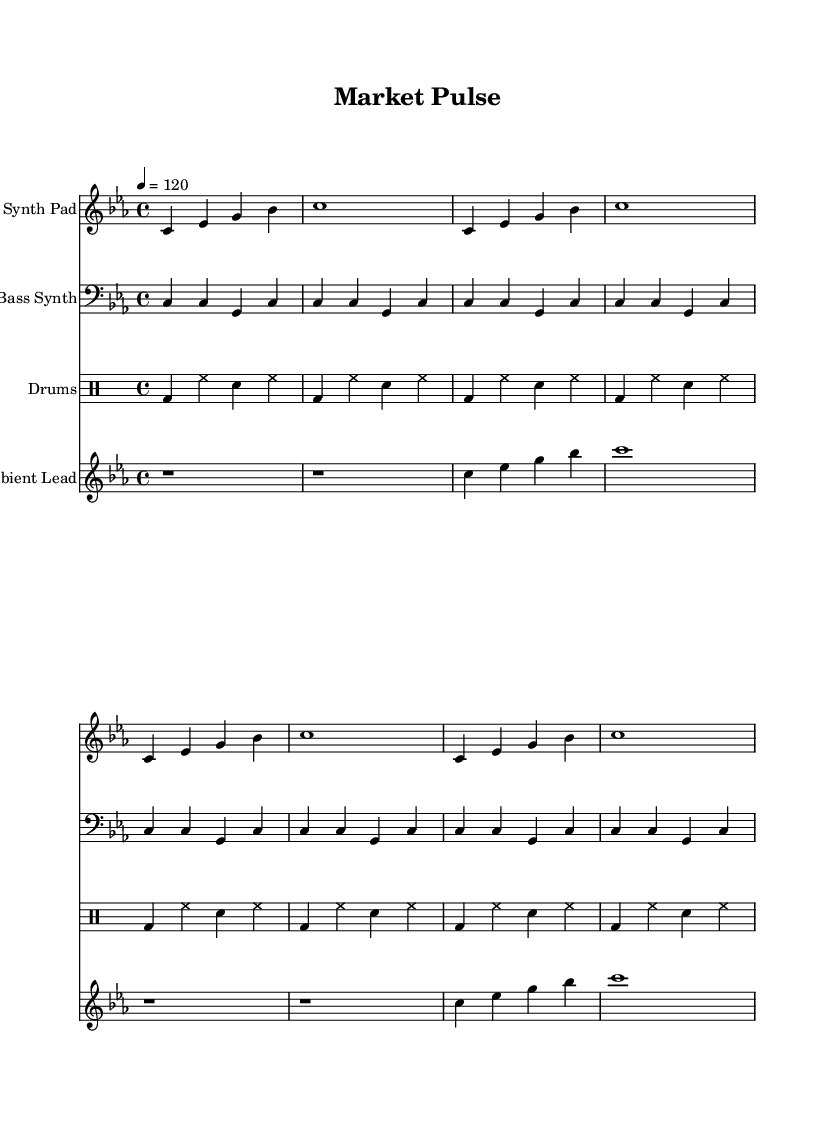What is the key signature of this music? The key signature is C minor, which has three flats: B flat, E flat, and A flat. This is indicated at the beginning of the staff.
Answer: C minor What is the time signature? The time signature is 4/4, which means there are four beats in each measure and the quarter note receives one beat. This is shown at the start of the piece after the key signature.
Answer: 4/4 What is the tempo marking? The tempo marking indicates a tempo of 120 beats per minute, which is notated at the beginning of the score as "4 = 120".
Answer: 120 How many measures are in the synth pad part? The synth pad part contains a total of eight measures, as counted from the beginning to the end of its section.
Answer: 8 What is the primary rhythmic pattern used in the drums part? The primary rhythmic pattern consists of a kick drum on the first and third beats and hi-hat on the second and fourth beats with snare accents in between, typical for house music.
Answer: Kick and hi-hat What note is sustained in the ambient lead during the first two measures? The ambient lead part sustains a rest for the first two measures, indicated by the "r" symbol, signifying silence during this time.
Answer: Rest How many different instruments are represented in the score? There are four different instruments represented: Synth Pad, Bass Synth, Drums, and Ambient Lead, as indicated by the different staves at the beginning of each part.
Answer: Four 